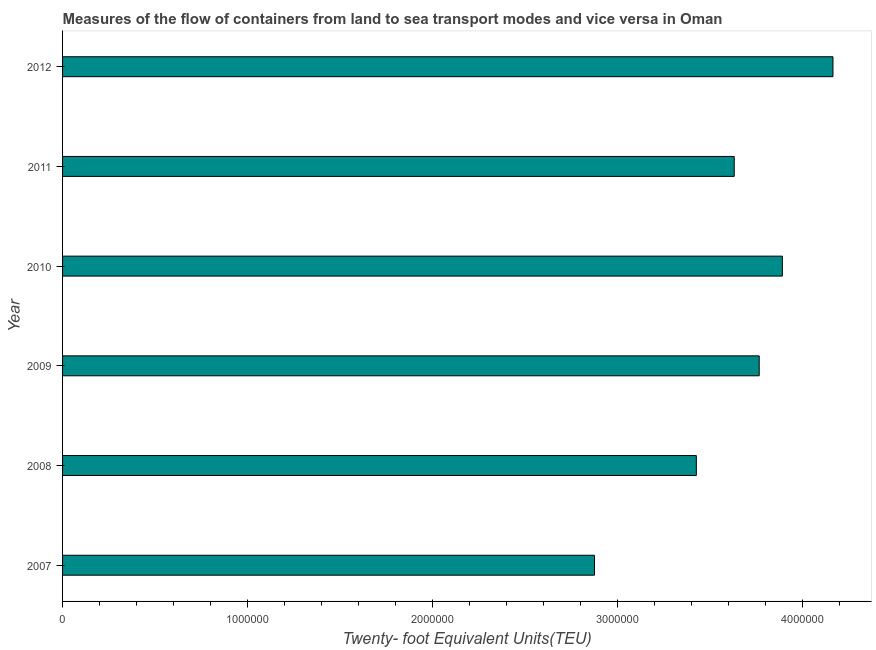What is the title of the graph?
Ensure brevity in your answer.  Measures of the flow of containers from land to sea transport modes and vice versa in Oman. What is the label or title of the X-axis?
Give a very brief answer. Twenty- foot Equivalent Units(TEU). What is the container port traffic in 2011?
Give a very brief answer. 3.63e+06. Across all years, what is the maximum container port traffic?
Give a very brief answer. 4.17e+06. Across all years, what is the minimum container port traffic?
Your response must be concise. 2.88e+06. What is the sum of the container port traffic?
Keep it short and to the point. 2.18e+07. What is the difference between the container port traffic in 2007 and 2011?
Offer a terse response. -7.56e+05. What is the average container port traffic per year?
Offer a terse response. 3.63e+06. What is the median container port traffic?
Provide a succinct answer. 3.70e+06. In how many years, is the container port traffic greater than 3200000 TEU?
Offer a very short reply. 5. Do a majority of the years between 2009 and 2012 (inclusive) have container port traffic greater than 800000 TEU?
Make the answer very short. Yes. What is the ratio of the container port traffic in 2007 to that in 2009?
Your answer should be compact. 0.76. Is the difference between the container port traffic in 2008 and 2009 greater than the difference between any two years?
Make the answer very short. No. What is the difference between the highest and the second highest container port traffic?
Keep it short and to the point. 2.74e+05. Is the sum of the container port traffic in 2009 and 2010 greater than the maximum container port traffic across all years?
Offer a very short reply. Yes. What is the difference between the highest and the lowest container port traffic?
Make the answer very short. 1.29e+06. Are all the bars in the graph horizontal?
Your answer should be compact. Yes. How many years are there in the graph?
Make the answer very short. 6. What is the Twenty- foot Equivalent Units(TEU) in 2007?
Ensure brevity in your answer.  2.88e+06. What is the Twenty- foot Equivalent Units(TEU) in 2008?
Make the answer very short. 3.43e+06. What is the Twenty- foot Equivalent Units(TEU) of 2009?
Keep it short and to the point. 3.77e+06. What is the Twenty- foot Equivalent Units(TEU) in 2010?
Offer a very short reply. 3.89e+06. What is the Twenty- foot Equivalent Units(TEU) in 2011?
Offer a very short reply. 3.63e+06. What is the Twenty- foot Equivalent Units(TEU) of 2012?
Make the answer very short. 4.17e+06. What is the difference between the Twenty- foot Equivalent Units(TEU) in 2007 and 2008?
Give a very brief answer. -5.51e+05. What is the difference between the Twenty- foot Equivalent Units(TEU) in 2007 and 2009?
Offer a very short reply. -8.91e+05. What is the difference between the Twenty- foot Equivalent Units(TEU) in 2007 and 2010?
Provide a succinct answer. -1.02e+06. What is the difference between the Twenty- foot Equivalent Units(TEU) in 2007 and 2011?
Offer a terse response. -7.56e+05. What is the difference between the Twenty- foot Equivalent Units(TEU) in 2007 and 2012?
Your response must be concise. -1.29e+06. What is the difference between the Twenty- foot Equivalent Units(TEU) in 2008 and 2009?
Your answer should be very brief. -3.40e+05. What is the difference between the Twenty- foot Equivalent Units(TEU) in 2008 and 2010?
Give a very brief answer. -4.65e+05. What is the difference between the Twenty- foot Equivalent Units(TEU) in 2008 and 2011?
Your answer should be very brief. -2.05e+05. What is the difference between the Twenty- foot Equivalent Units(TEU) in 2008 and 2012?
Provide a short and direct response. -7.39e+05. What is the difference between the Twenty- foot Equivalent Units(TEU) in 2009 and 2010?
Offer a very short reply. -1.25e+05. What is the difference between the Twenty- foot Equivalent Units(TEU) in 2009 and 2011?
Your answer should be very brief. 1.35e+05. What is the difference between the Twenty- foot Equivalent Units(TEU) in 2009 and 2012?
Keep it short and to the point. -3.99e+05. What is the difference between the Twenty- foot Equivalent Units(TEU) in 2010 and 2011?
Make the answer very short. 2.60e+05. What is the difference between the Twenty- foot Equivalent Units(TEU) in 2010 and 2012?
Ensure brevity in your answer.  -2.74e+05. What is the difference between the Twenty- foot Equivalent Units(TEU) in 2011 and 2012?
Provide a succinct answer. -5.34e+05. What is the ratio of the Twenty- foot Equivalent Units(TEU) in 2007 to that in 2008?
Your answer should be very brief. 0.84. What is the ratio of the Twenty- foot Equivalent Units(TEU) in 2007 to that in 2009?
Your answer should be compact. 0.76. What is the ratio of the Twenty- foot Equivalent Units(TEU) in 2007 to that in 2010?
Provide a succinct answer. 0.74. What is the ratio of the Twenty- foot Equivalent Units(TEU) in 2007 to that in 2011?
Offer a terse response. 0.79. What is the ratio of the Twenty- foot Equivalent Units(TEU) in 2007 to that in 2012?
Offer a very short reply. 0.69. What is the ratio of the Twenty- foot Equivalent Units(TEU) in 2008 to that in 2009?
Offer a very short reply. 0.91. What is the ratio of the Twenty- foot Equivalent Units(TEU) in 2008 to that in 2010?
Offer a terse response. 0.88. What is the ratio of the Twenty- foot Equivalent Units(TEU) in 2008 to that in 2011?
Provide a succinct answer. 0.94. What is the ratio of the Twenty- foot Equivalent Units(TEU) in 2008 to that in 2012?
Your response must be concise. 0.82. What is the ratio of the Twenty- foot Equivalent Units(TEU) in 2009 to that in 2011?
Your response must be concise. 1.04. What is the ratio of the Twenty- foot Equivalent Units(TEU) in 2009 to that in 2012?
Keep it short and to the point. 0.9. What is the ratio of the Twenty- foot Equivalent Units(TEU) in 2010 to that in 2011?
Give a very brief answer. 1.07. What is the ratio of the Twenty- foot Equivalent Units(TEU) in 2010 to that in 2012?
Ensure brevity in your answer.  0.93. What is the ratio of the Twenty- foot Equivalent Units(TEU) in 2011 to that in 2012?
Ensure brevity in your answer.  0.87. 